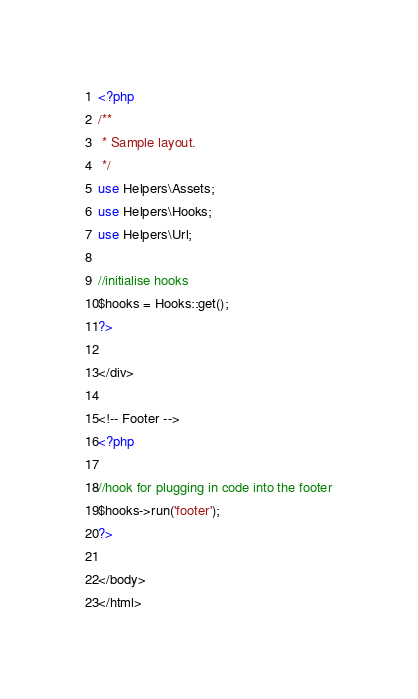Convert code to text. <code><loc_0><loc_0><loc_500><loc_500><_PHP_><?php
/**
 * Sample layout.
 */
use Helpers\Assets;
use Helpers\Hooks;
use Helpers\Url;

//initialise hooks
$hooks = Hooks::get();
?>

</div>

<!-- Footer -->
<?php

//hook for plugging in code into the footer
$hooks->run('footer');
?>

</body>
</html>
</code> 